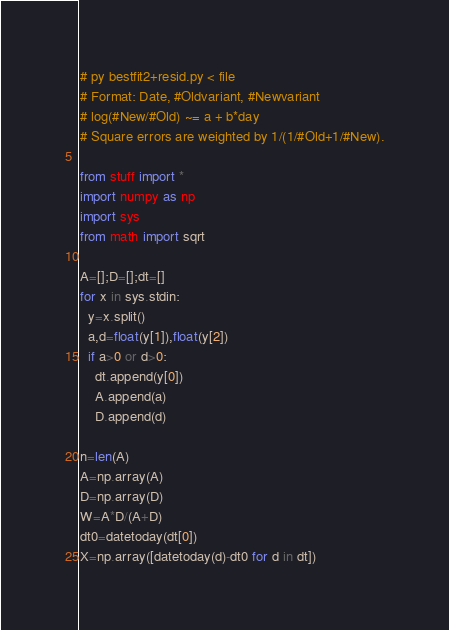<code> <loc_0><loc_0><loc_500><loc_500><_Python_># py bestfit2+resid.py < file
# Format: Date, #Oldvariant, #Newvariant
# log(#New/#Old) ~= a + b*day
# Square errors are weighted by 1/(1/#Old+1/#New).

from stuff import *
import numpy as np
import sys
from math import sqrt

A=[];D=[];dt=[]
for x in sys.stdin:
  y=x.split()
  a,d=float(y[1]),float(y[2])
  if a>0 or d>0:
    dt.append(y[0])
    A.append(a)
    D.append(d)

n=len(A)
A=np.array(A)
D=np.array(D)
W=A*D/(A+D)
dt0=datetoday(dt[0])
X=np.array([datetoday(d)-dt0 for d in dt])</code> 